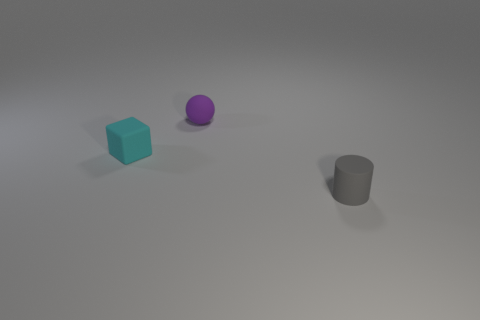How big is the gray matte cylinder that is in front of the object left of the tiny rubber ball?
Provide a short and direct response. Small. How many large things are cylinders or brown things?
Your answer should be compact. 0. Does the tiny purple sphere have the same material as the tiny thing that is left of the small purple sphere?
Provide a short and direct response. Yes. Is the number of cyan blocks behind the gray matte cylinder greater than the number of tiny rubber blocks behind the small purple matte thing?
Make the answer very short. Yes. The tiny rubber object that is to the right of the tiny matte thing behind the tiny cyan cube is what color?
Provide a short and direct response. Gray. How many cylinders are tiny purple rubber objects or small cyan objects?
Give a very brief answer. 0. How many small objects are both to the right of the small purple object and behind the gray matte object?
Ensure brevity in your answer.  0. The object that is behind the cyan matte cube is what color?
Provide a short and direct response. Purple. There is a small cyan thing that is in front of the purple ball; what number of tiny matte cylinders are on the left side of it?
Your answer should be very brief. 0. There is a small purple matte object; what number of matte cylinders are behind it?
Provide a succinct answer. 0. 